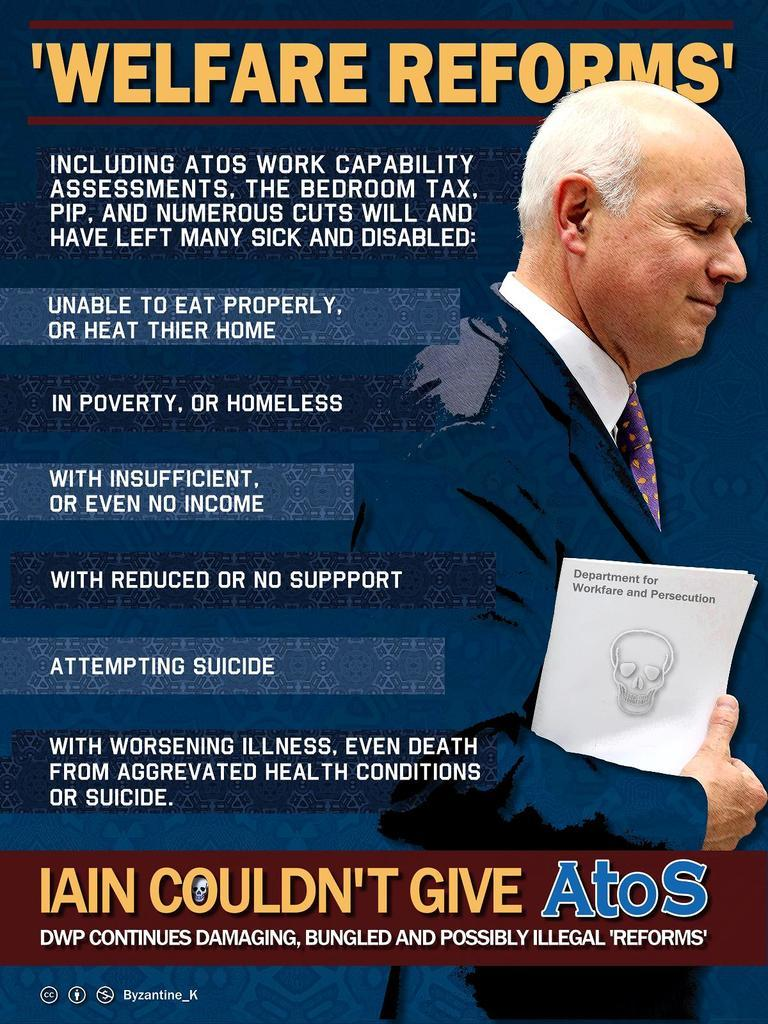What is featured on the poster in the image? There is a poster in the image, and it has an image of a person holding paper. What else can be seen on the poster besides the image? There is text on the poster. Can you hear the bird laughing in the image? There is no bird or laughter present in the image; it only features a poster with an image of a person holding paper and text. 